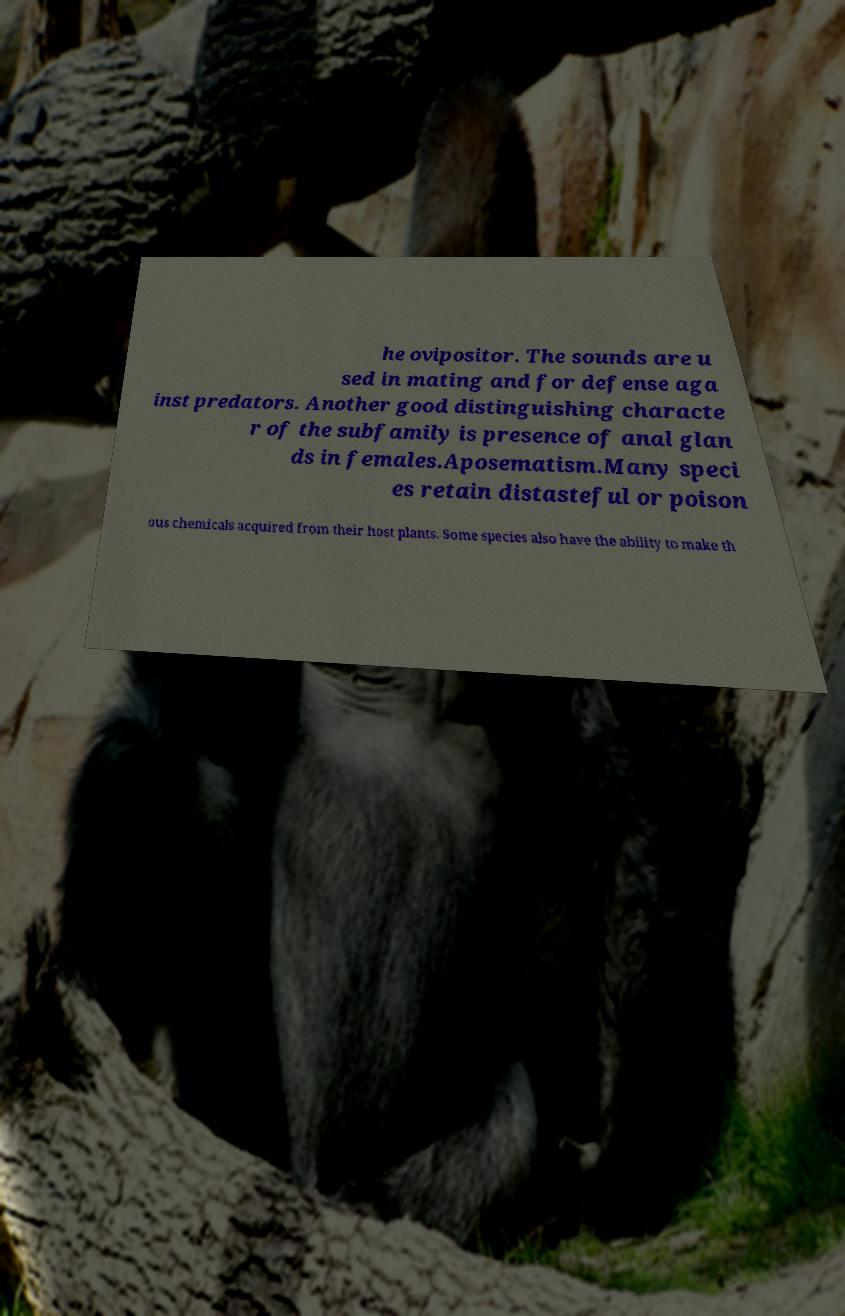There's text embedded in this image that I need extracted. Can you transcribe it verbatim? he ovipositor. The sounds are u sed in mating and for defense aga inst predators. Another good distinguishing characte r of the subfamily is presence of anal glan ds in females.Aposematism.Many speci es retain distasteful or poison ous chemicals acquired from their host plants. Some species also have the ability to make th 